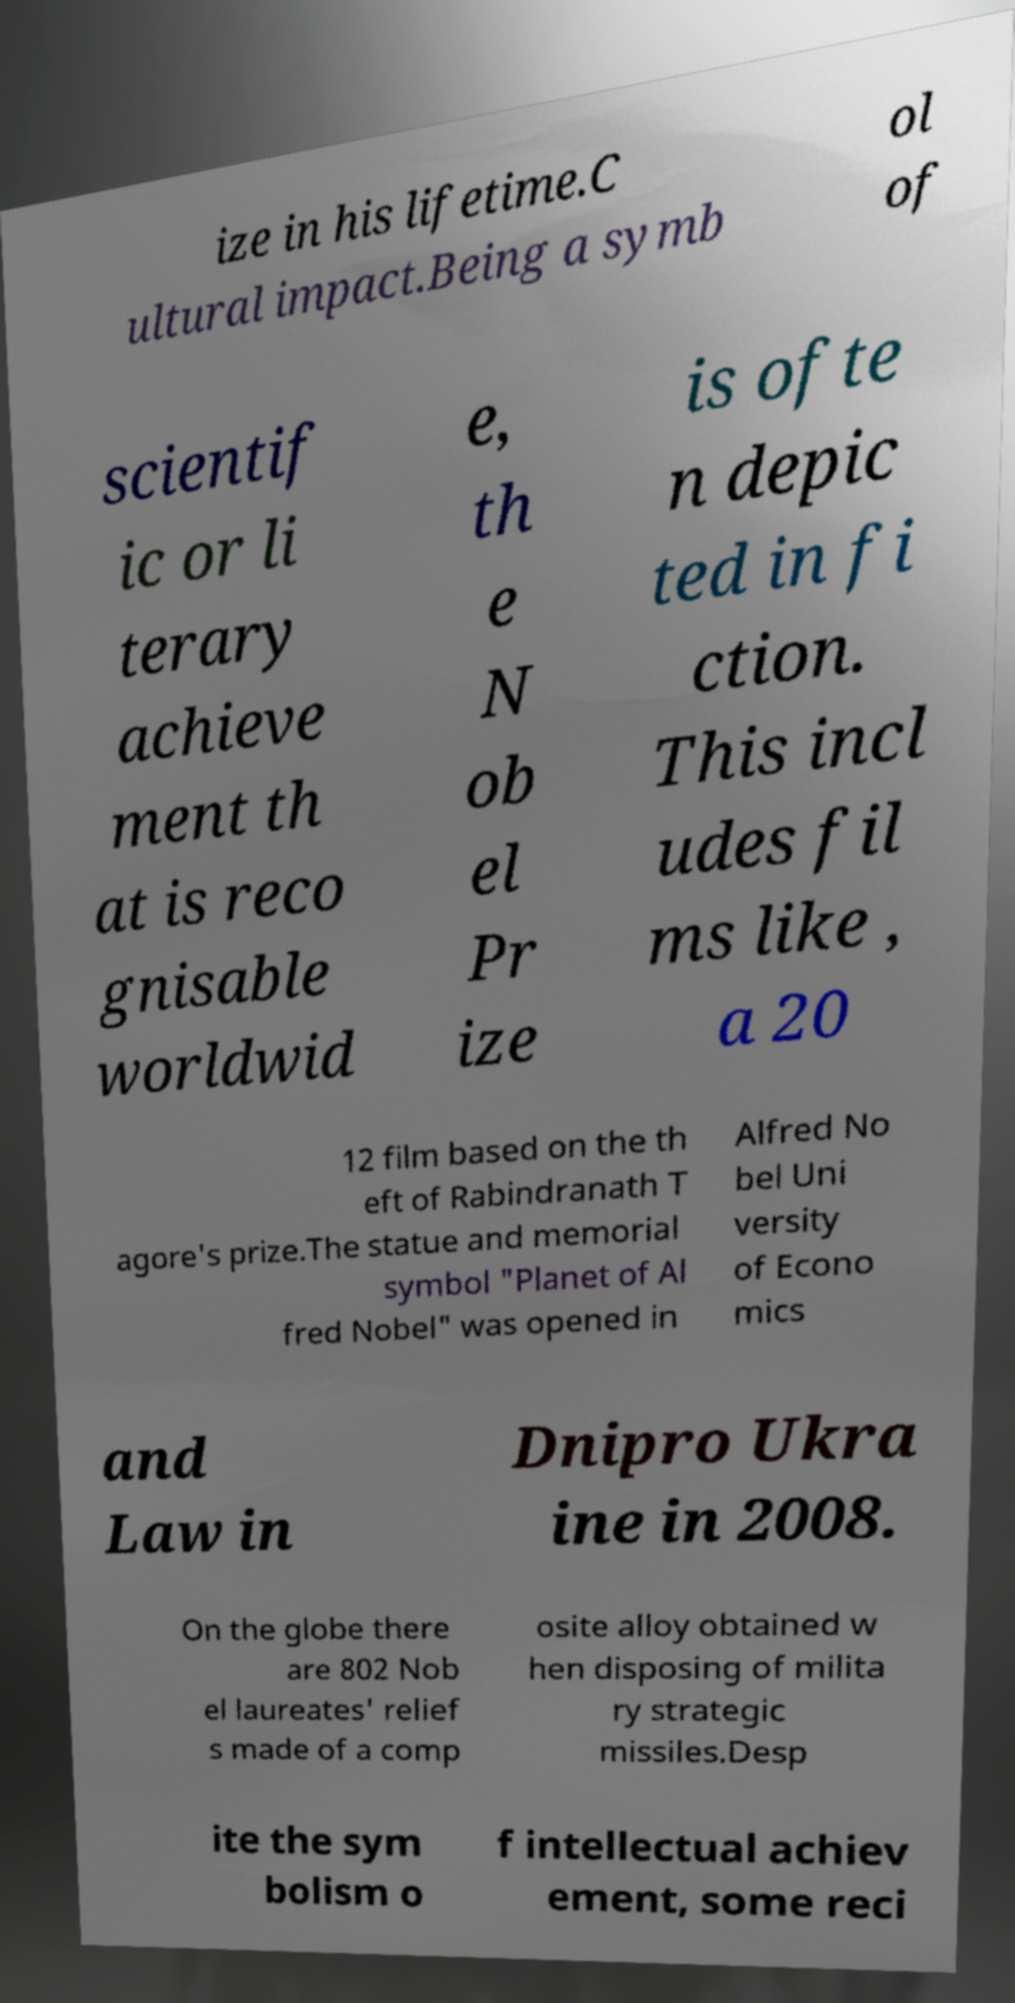I need the written content from this picture converted into text. Can you do that? ize in his lifetime.C ultural impact.Being a symb ol of scientif ic or li terary achieve ment th at is reco gnisable worldwid e, th e N ob el Pr ize is ofte n depic ted in fi ction. This incl udes fil ms like , a 20 12 film based on the th eft of Rabindranath T agore's prize.The statue and memorial symbol "Planet of Al fred Nobel" was opened in Alfred No bel Uni versity of Econo mics and Law in Dnipro Ukra ine in 2008. On the globe there are 802 Nob el laureates' relief s made of a comp osite alloy obtained w hen disposing of milita ry strategic missiles.Desp ite the sym bolism o f intellectual achiev ement, some reci 